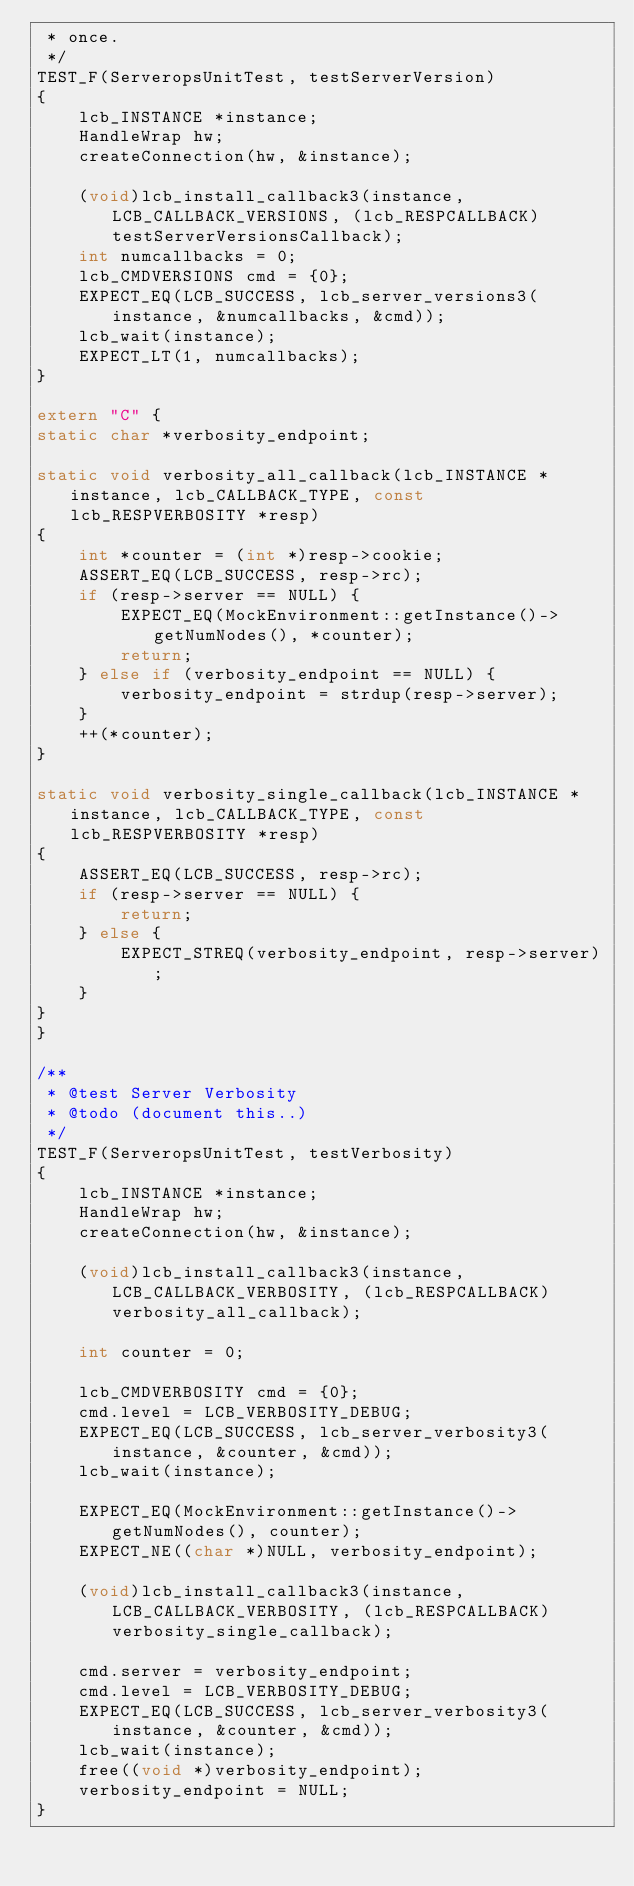<code> <loc_0><loc_0><loc_500><loc_500><_C++_> * once.
 */
TEST_F(ServeropsUnitTest, testServerVersion)
{
    lcb_INSTANCE *instance;
    HandleWrap hw;
    createConnection(hw, &instance);

    (void)lcb_install_callback3(instance, LCB_CALLBACK_VERSIONS, (lcb_RESPCALLBACK)testServerVersionsCallback);
    int numcallbacks = 0;
    lcb_CMDVERSIONS cmd = {0};
    EXPECT_EQ(LCB_SUCCESS, lcb_server_versions3(instance, &numcallbacks, &cmd));
    lcb_wait(instance);
    EXPECT_LT(1, numcallbacks);
}

extern "C" {
static char *verbosity_endpoint;

static void verbosity_all_callback(lcb_INSTANCE *instance, lcb_CALLBACK_TYPE, const lcb_RESPVERBOSITY *resp)
{
    int *counter = (int *)resp->cookie;
    ASSERT_EQ(LCB_SUCCESS, resp->rc);
    if (resp->server == NULL) {
        EXPECT_EQ(MockEnvironment::getInstance()->getNumNodes(), *counter);
        return;
    } else if (verbosity_endpoint == NULL) {
        verbosity_endpoint = strdup(resp->server);
    }
    ++(*counter);
}

static void verbosity_single_callback(lcb_INSTANCE *instance, lcb_CALLBACK_TYPE, const lcb_RESPVERBOSITY *resp)
{
    ASSERT_EQ(LCB_SUCCESS, resp->rc);
    if (resp->server == NULL) {
        return;
    } else {
        EXPECT_STREQ(verbosity_endpoint, resp->server);
    }
}
}

/**
 * @test Server Verbosity
 * @todo (document this..)
 */
TEST_F(ServeropsUnitTest, testVerbosity)
{
    lcb_INSTANCE *instance;
    HandleWrap hw;
    createConnection(hw, &instance);

    (void)lcb_install_callback3(instance, LCB_CALLBACK_VERBOSITY, (lcb_RESPCALLBACK)verbosity_all_callback);

    int counter = 0;

    lcb_CMDVERBOSITY cmd = {0};
    cmd.level = LCB_VERBOSITY_DEBUG;
    EXPECT_EQ(LCB_SUCCESS, lcb_server_verbosity3(instance, &counter, &cmd));
    lcb_wait(instance);

    EXPECT_EQ(MockEnvironment::getInstance()->getNumNodes(), counter);
    EXPECT_NE((char *)NULL, verbosity_endpoint);

    (void)lcb_install_callback3(instance, LCB_CALLBACK_VERBOSITY, (lcb_RESPCALLBACK)verbosity_single_callback);

    cmd.server = verbosity_endpoint;
    cmd.level = LCB_VERBOSITY_DEBUG;
    EXPECT_EQ(LCB_SUCCESS, lcb_server_verbosity3(instance, &counter, &cmd));
    lcb_wait(instance);
    free((void *)verbosity_endpoint);
    verbosity_endpoint = NULL;
}
</code> 